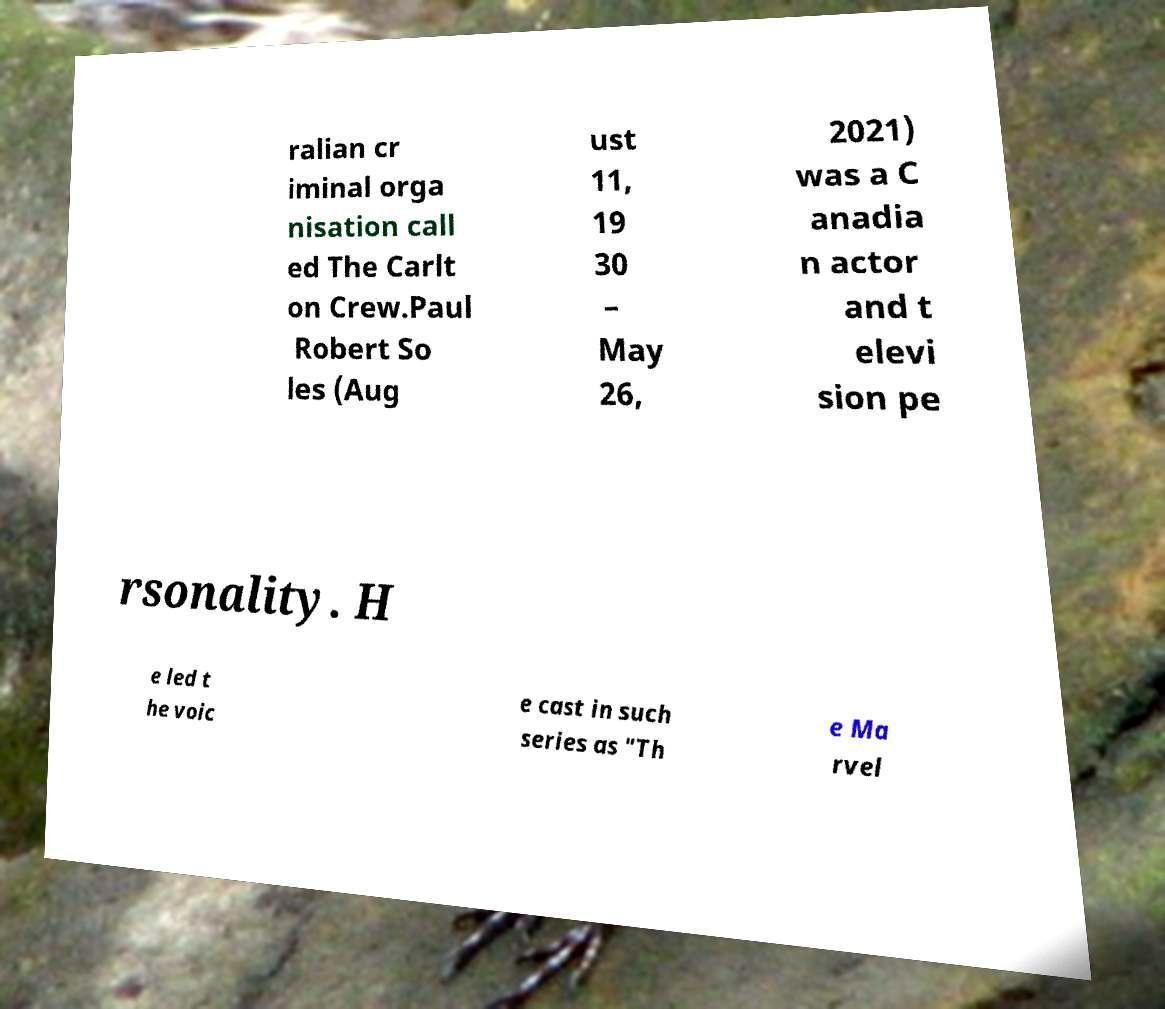What messages or text are displayed in this image? I need them in a readable, typed format. ralian cr iminal orga nisation call ed The Carlt on Crew.Paul Robert So les (Aug ust 11, 19 30 – May 26, 2021) was a C anadia n actor and t elevi sion pe rsonality. H e led t he voic e cast in such series as "Th e Ma rvel 